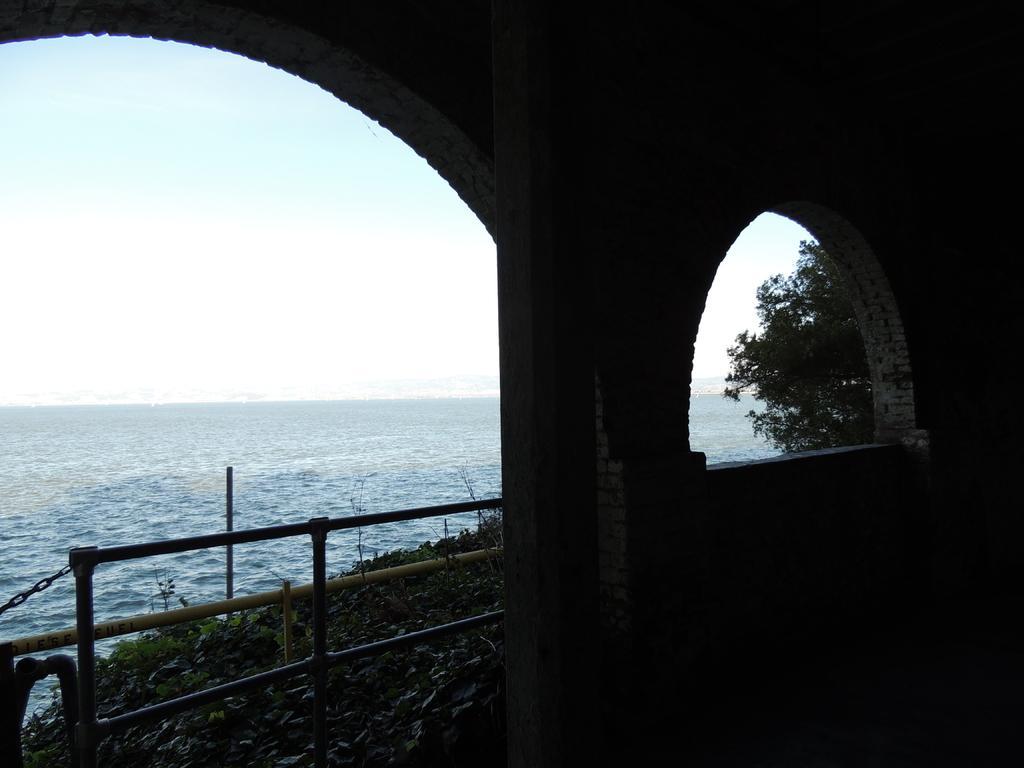In one or two sentences, can you explain what this image depicts? In this image we can see water, plants, trees, building and sky. 